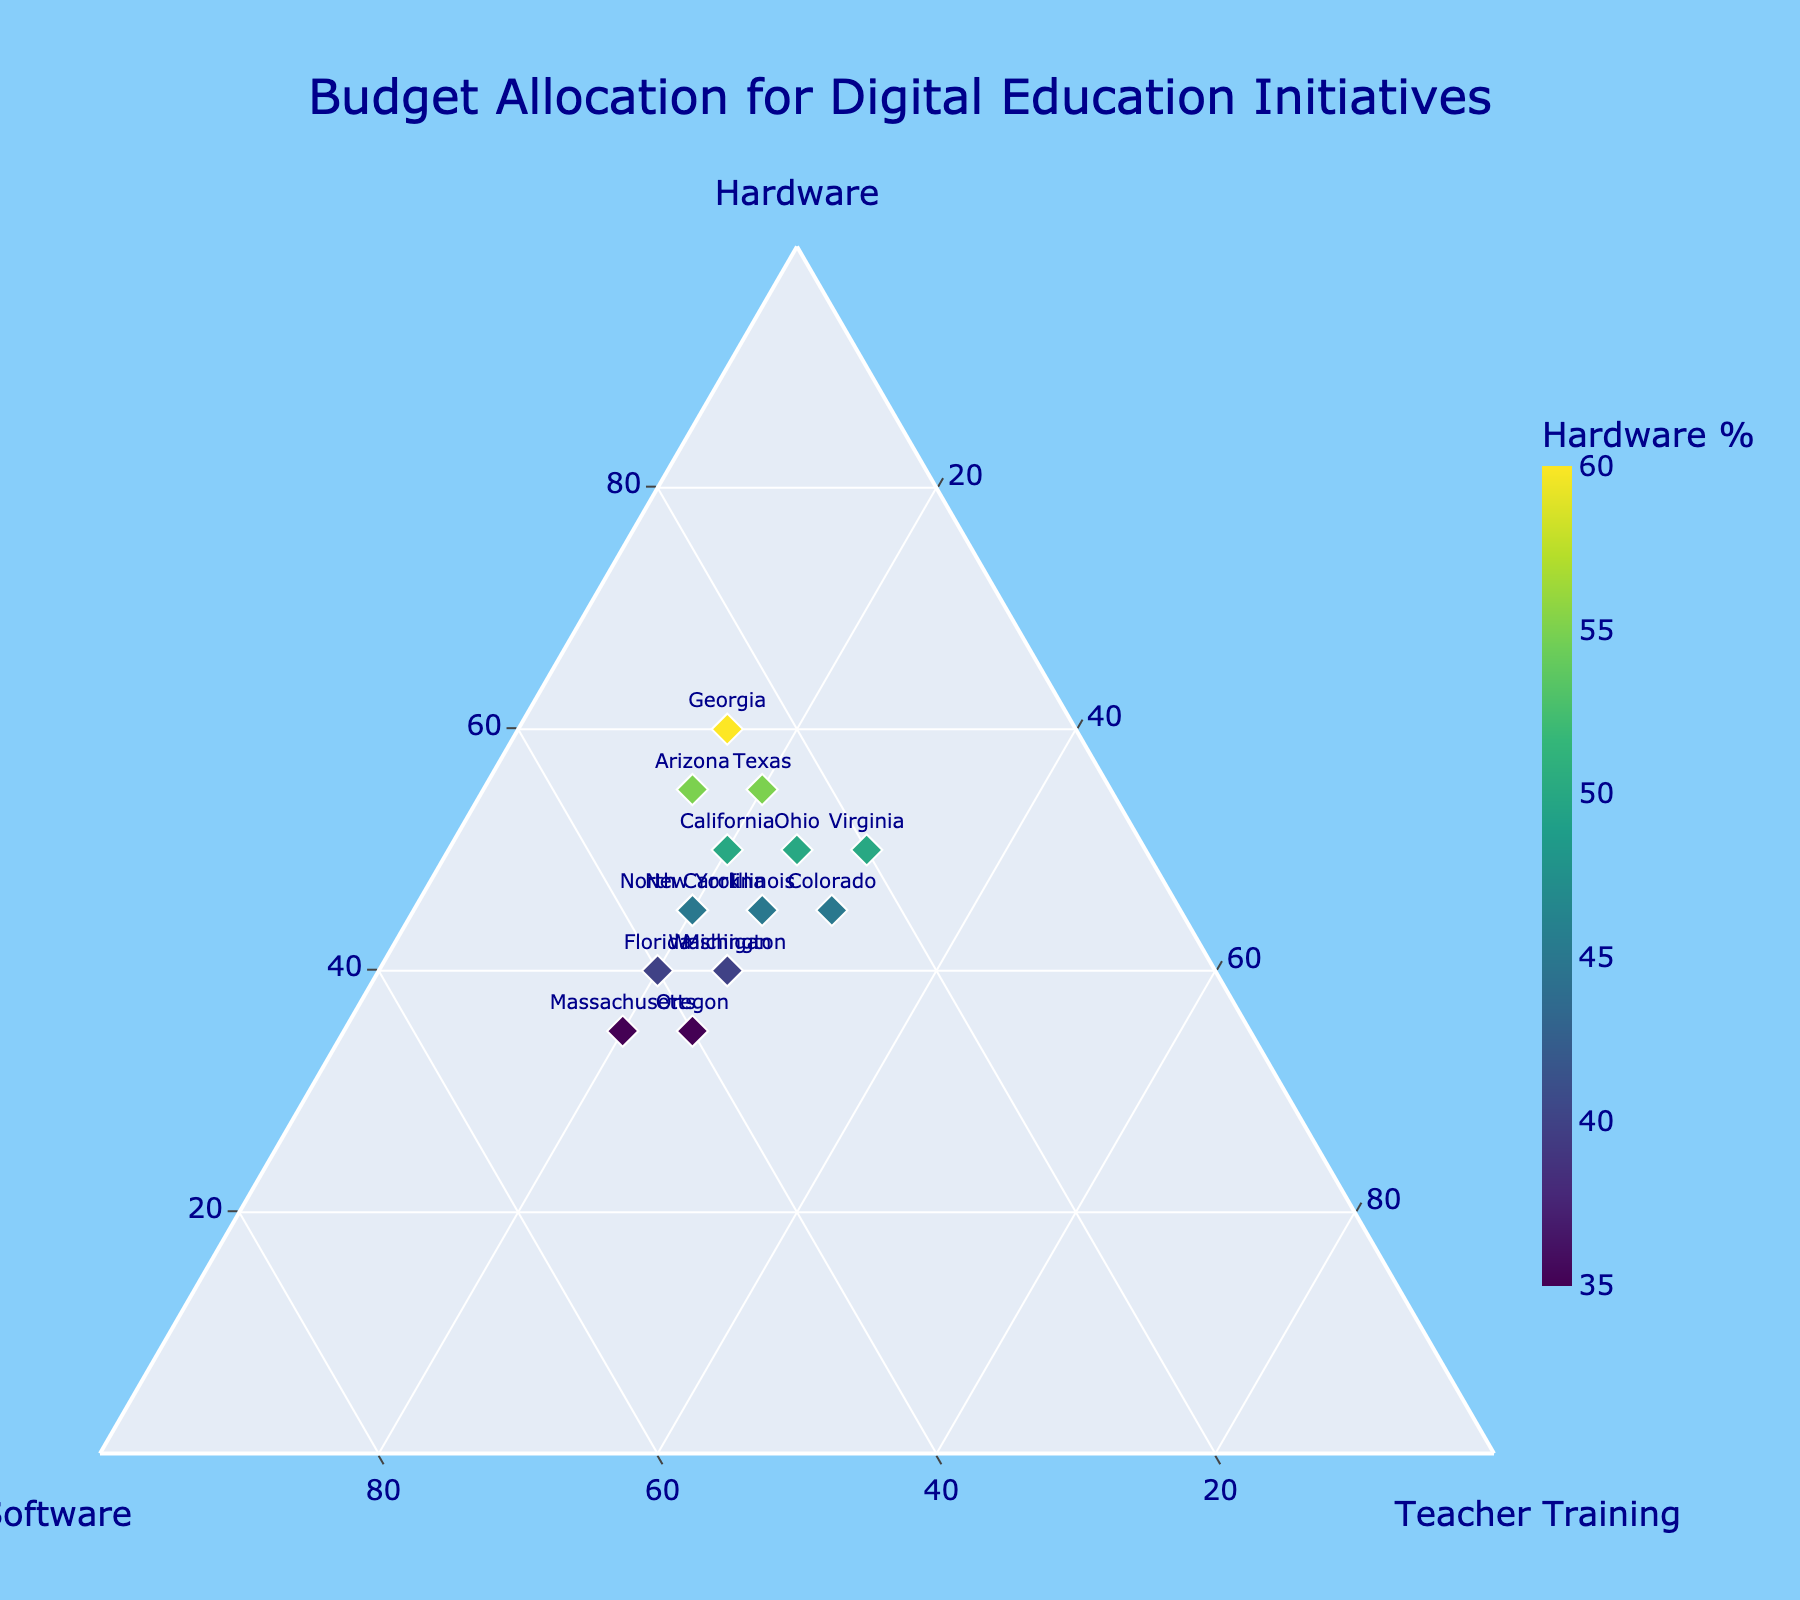What's the title of the ternary plot? The title is located at the top center of the ternary plot.
Answer: Budget Allocation for Digital Education Initiatives What are the three budget categories shown in the plot? The budget categories are the labels on each axis of the ternary plot.
Answer: Hardware, Software, Teacher Training Which state allocates the highest percentage of the budget to Hardware? The state with the highest point on the Hardware axis allocates the most budget to Hardware.
Answer: Georgia Comparing Massachusetts and Texas, which state allocates a higher percentage to Software? Locate the points for Massachusetts and Texas and compare their positions along the Software axis.
Answer: Massachusetts What is the range of percentages allocated to Teacher Training across the states? Check the minimum and maximum values on the Teacher Training axis.
Answer: 15% to 30% Which state has an equal allocation between Hardware and Teacher Training? Look for the point where the values for Hardware and Teacher Training are equal; this state should lie along the axis line between Hardware and Teacher Training.
Answer: Virginia What is the average percentage allocation for Software across all states? Sum up all Software percentages and divide by the number of states (15). (30+35+25+40+30+45+35+40+25+20+25+30+35+35+25) / 15 = 32.67
Answer: 32.67% Which states allocate more budget to Teacher Training than to Software? Compare for each state if its percentage for Teacher Training is greater than for Software.
Answer: Colorado, Virginia Among California, New York, and Texas, which state allocates the least to Teacher Training? Identify the percentages allocated to Teacher Training for these states and find the lowest value.
Answer: California, New York, Texas all allocate 20% to Teacher Training 